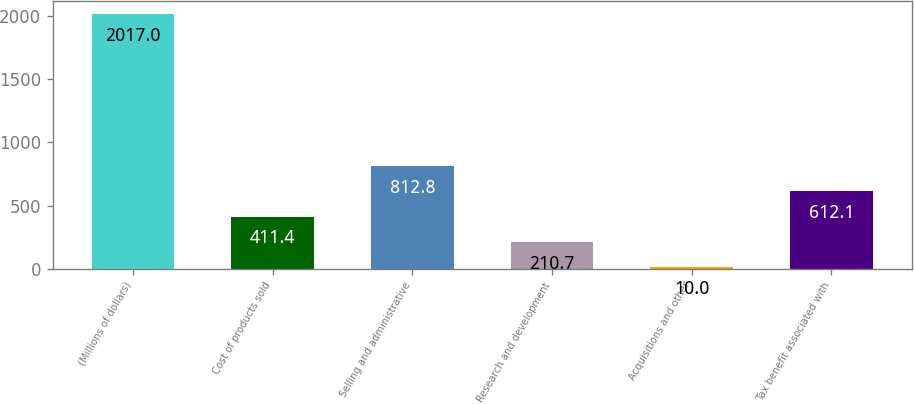Convert chart to OTSL. <chart><loc_0><loc_0><loc_500><loc_500><bar_chart><fcel>(Millions of dollars)<fcel>Cost of products sold<fcel>Selling and administrative<fcel>Research and development<fcel>Acquisitions and other<fcel>Tax benefit associated with<nl><fcel>2017<fcel>411.4<fcel>812.8<fcel>210.7<fcel>10<fcel>612.1<nl></chart> 